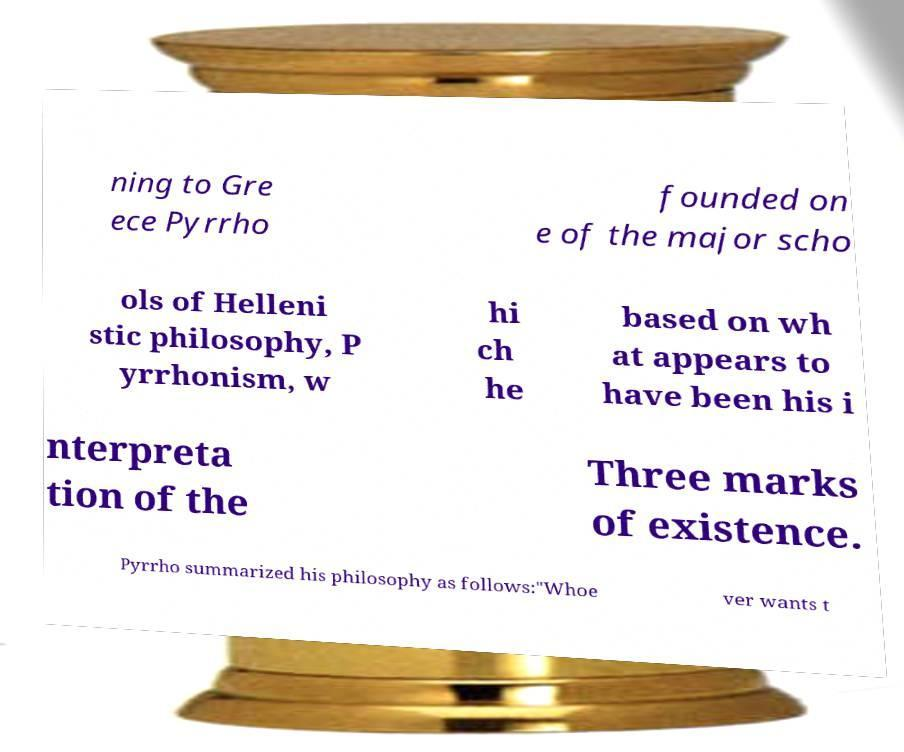I need the written content from this picture converted into text. Can you do that? ning to Gre ece Pyrrho founded on e of the major scho ols of Helleni stic philosophy, P yrrhonism, w hi ch he based on wh at appears to have been his i nterpreta tion of the Three marks of existence. Pyrrho summarized his philosophy as follows:"Whoe ver wants t 